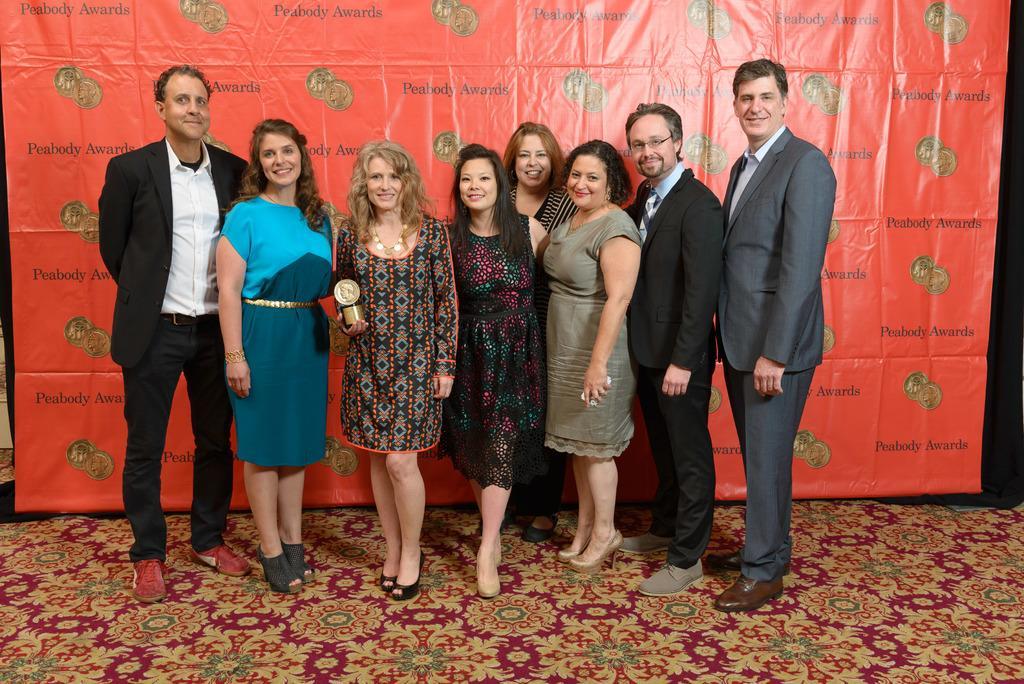Describe this image in one or two sentences. In this image we can see a few people are standing on the floor with a smile, one of them is holding an award, behind them there is a banner. 